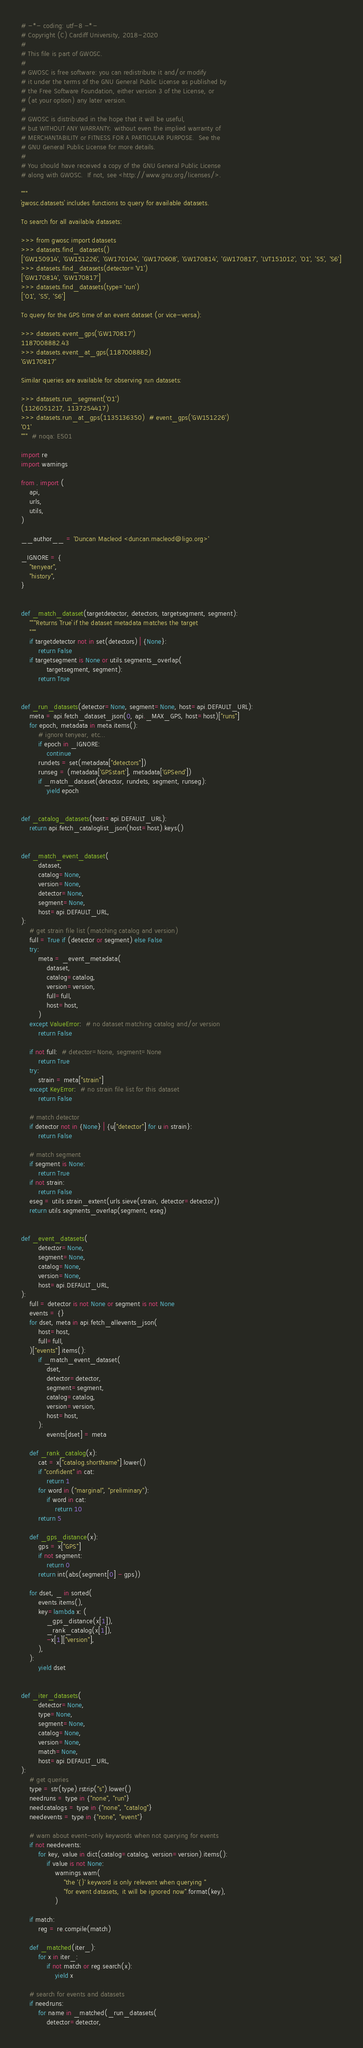Convert code to text. <code><loc_0><loc_0><loc_500><loc_500><_Python_># -*- coding: utf-8 -*-
# Copyright (C) Cardiff University, 2018-2020
#
# This file is part of GWOSC.
#
# GWOSC is free software: you can redistribute it and/or modify
# it under the terms of the GNU General Public License as published by
# the Free Software Foundation, either version 3 of the License, or
# (at your option) any later version.
#
# GWOSC is distributed in the hope that it will be useful,
# but WITHOUT ANY WARRANTY; without even the implied warranty of
# MERCHANTABILITY or FITNESS FOR A PARTICULAR PURPOSE.  See the
# GNU General Public License for more details.
#
# You should have received a copy of the GNU General Public License
# along with GWOSC.  If not, see <http://www.gnu.org/licenses/>.

"""
`gwosc.datasets` includes functions to query for available datasets.

To search for all available datasets:

>>> from gwosc import datasets
>>> datasets.find_datasets()
['GW150914', 'GW151226', 'GW170104', 'GW170608', 'GW170814', 'GW170817', 'LVT151012', 'O1', 'S5', 'S6']
>>> datasets.find_datasets(detector='V1')
['GW170814', 'GW170817']
>>> datasets.find_datasets(type='run')
['O1', 'S5', 'S6']

To query for the GPS time of an event dataset (or vice-versa):

>>> datasets.event_gps('GW170817')
1187008882.43
>>> datasets.event_at_gps(1187008882)
'GW170817'

Similar queries are available for observing run datasets:

>>> datasets.run_segment('O1')
(1126051217, 1137254417)
>>> datasets.run_at_gps(1135136350)  # event_gps('GW151226')
'O1'
"""  # noqa: E501

import re
import warnings

from . import (
    api,
    urls,
    utils,
)

__author__ = 'Duncan Macleod <duncan.macleod@ligo.org>'

_IGNORE = {
    "tenyear",
    "history",
}


def _match_dataset(targetdetector, detectors, targetsegment, segment):
    """Returns `True` if the dataset metadata matches the target
    """
    if targetdetector not in set(detectors) | {None}:
        return False
    if targetsegment is None or utils.segments_overlap(
            targetsegment, segment):
        return True


def _run_datasets(detector=None, segment=None, host=api.DEFAULT_URL):
    meta = api.fetch_dataset_json(0, api._MAX_GPS, host=host)["runs"]
    for epoch, metadata in meta.items():
        # ignore tenyear, etc...
        if epoch in _IGNORE:
            continue
        rundets = set(metadata["detectors"])
        runseg = (metadata['GPSstart'], metadata['GPSend'])
        if _match_dataset(detector, rundets, segment, runseg):
            yield epoch


def _catalog_datasets(host=api.DEFAULT_URL):
    return api.fetch_cataloglist_json(host=host).keys()


def _match_event_dataset(
        dataset,
        catalog=None,
        version=None,
        detector=None,
        segment=None,
        host=api.DEFAULT_URL,
):
    # get strain file list (matching catalog and version)
    full = True if (detector or segment) else False
    try:
        meta = _event_metadata(
            dataset,
            catalog=catalog,
            version=version,
            full=full,
            host=host,
        )
    except ValueError:  # no dataset matching catalog and/or version
        return False

    if not full:  # detector=None, segment=None
        return True
    try:
        strain = meta["strain"]
    except KeyError:  # no strain file list for this dataset
        return False

    # match detector
    if detector not in {None} | {u["detector"] for u in strain}:
        return False

    # match segment
    if segment is None:
        return True
    if not strain:
        return False
    eseg = utils.strain_extent(urls.sieve(strain, detector=detector))
    return utils.segments_overlap(segment, eseg)


def _event_datasets(
        detector=None,
        segment=None,
        catalog=None,
        version=None,
        host=api.DEFAULT_URL,
):
    full = detector is not None or segment is not None
    events = {}
    for dset, meta in api.fetch_allevents_json(
        host=host,
        full=full,
    )["events"].items():
        if _match_event_dataset(
            dset,
            detector=detector,
            segment=segment,
            catalog=catalog,
            version=version,
            host=host,
        ):
            events[dset] = meta

    def _rank_catalog(x):
        cat = x["catalog.shortName"].lower()
        if "confident" in cat:
            return 1
        for word in ("marginal", "preliminary"):
            if word in cat:
                return 10
        return 5

    def _gps_distance(x):
        gps = x["GPS"]
        if not segment:
            return 0
        return int(abs(segment[0] - gps))

    for dset, _ in sorted(
        events.items(),
        key=lambda x: (
            _gps_distance(x[1]),
            _rank_catalog(x[1]),
            -x[1]["version"],
        ),
    ):
        yield dset


def _iter_datasets(
        detector=None,
        type=None,
        segment=None,
        catalog=None,
        version=None,
        match=None,
        host=api.DEFAULT_URL,
):
    # get queries
    type = str(type).rstrip("s").lower()
    needruns = type in {"none", "run"}
    needcatalogs = type in {"none", "catalog"}
    needevents = type in {"none", "event"}

    # warn about event-only keywords when not querying for events
    if not needevents:
        for key, value in dict(catalog=catalog, version=version).items():
            if value is not None:
                warnings.warn(
                    "the '{}' keyword is only relevant when querying "
                    "for event datasets, it will be ignored now".format(key),
                )

    if match:
        reg = re.compile(match)

    def _matched(iter_):
        for x in iter_:
            if not match or reg.search(x):
                yield x

    # search for events and datasets
    if needruns:
        for name in _matched(_run_datasets(
            detector=detector,</code> 